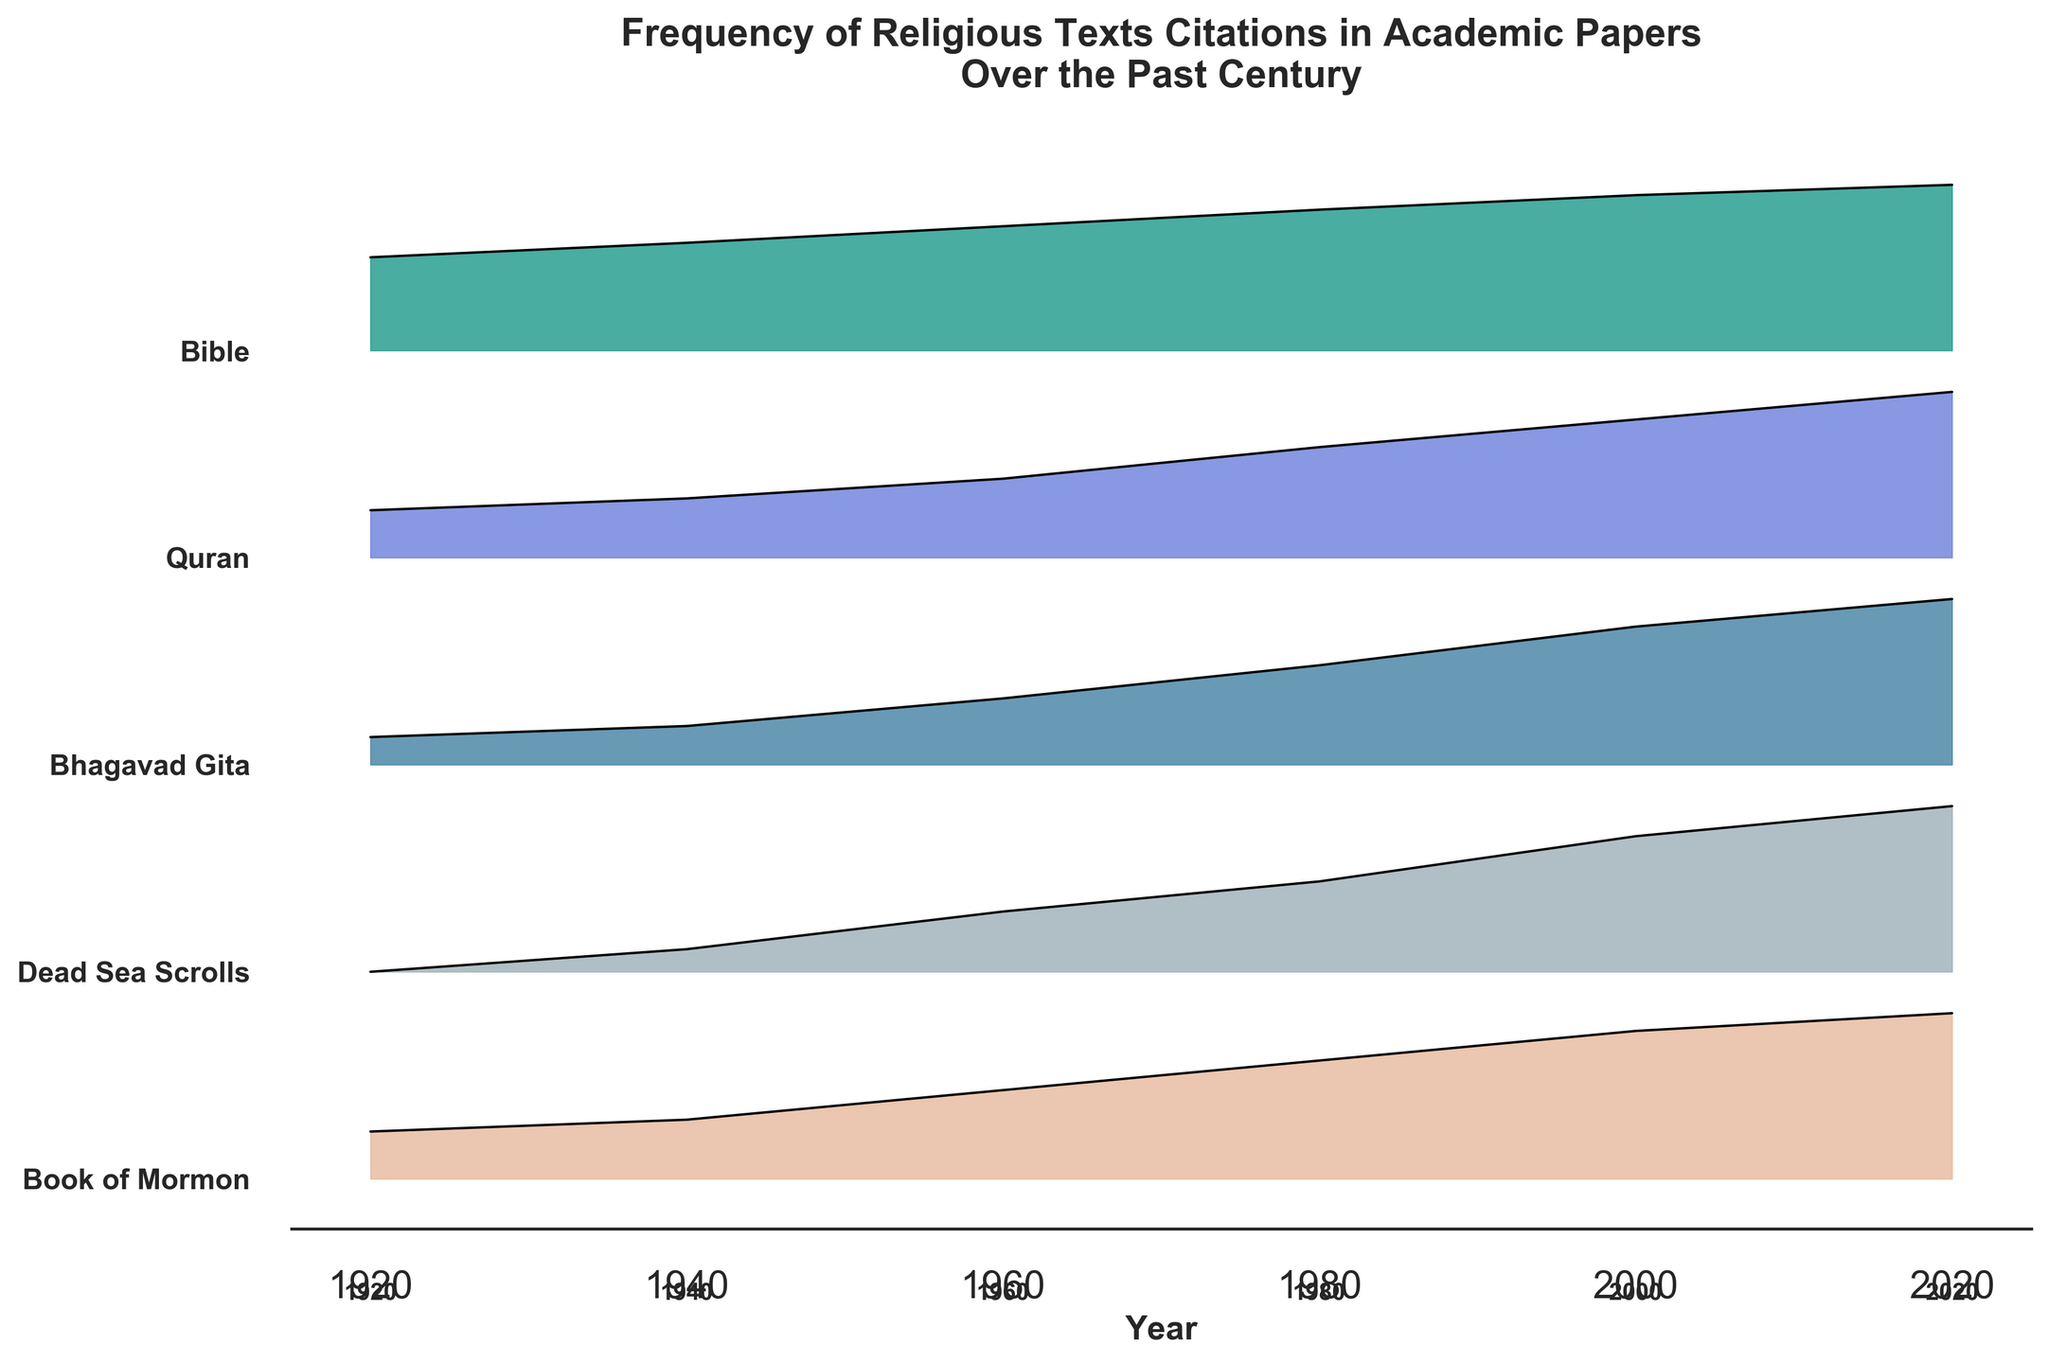What's the title of the figure? The title is usually placed at the top of the figure, in bold and larger font compared to other text. The title in this figure is "Frequency of Religious Texts Citations in Academic Papers Over the Past Century".
Answer: Frequency of Religious Texts Citations in Academic Papers Over the Past Century Which religious text had the highest citation frequency in 2020? By looking at the y-axis labels and tracing the year 2020 (the furthest point to the right), the "Bible" has the highest peak, suggesting it had the highest citation frequency in that year.
Answer: Bible How many religious texts are compared in this plot? The y-axis labels list the names of the religious texts. By counting them, we see there are five: Bible, Quran, Bhagavad Gita, Dead Sea Scrolls, and Book of Mormon.
Answer: Five What religious text had the most citations in 1940 and how many? For the year 1940, we trace back the line to the specific text with the highest peak. The "Bible" has the highest citation frequency in 1940 with approximately 52 citations.
Answer: Bible, 52 Which religious text saw the greatest increase in citation frequency from 1980 to 2000? Calculate the difference in citation numbers between 1980 and 2000 for each religious text and compare. The "Quran" increased from 28 to 35, which is an increase of 7 citations, the highest increase among the texts.
Answer: Quran What is the average number of citations across all religious texts in the year 1960? Sum up all the citations for 1960: 60 (Bible) + 20 (Quran) + 12 (Bhagavad Gita) + 8 (Dead Sea Scrolls) + 15 (Book of Mormon) = 115. Then, divide by the number of texts (5): 115/5 = 23.
Answer: 23 In which decade did the Dead Sea Scrolls first start getting cited in academic papers? The Dead Sea Scrolls show their first citations in the plot starting in 1940.
Answer: 1940s Between 2000 and 2020, which text shows the smallest increase in citation frequency? By calculating the difference between citation numbers in 2000 and 2020 for each text, we see that the "Book of Mormon" increased from 25 to 28, an increase of only 3, the smallest among the texts.
Answer: Book of Mormon Between the years 1920 and 1940, which text had the highest citation frequency increase? Calculate the difference in citation numbers between 1920 and 1940 for each religious text and compare. The "Bible" increased from 45 to 52, which is a 7 citation increase, the highest among the texts.
Answer: Bible 